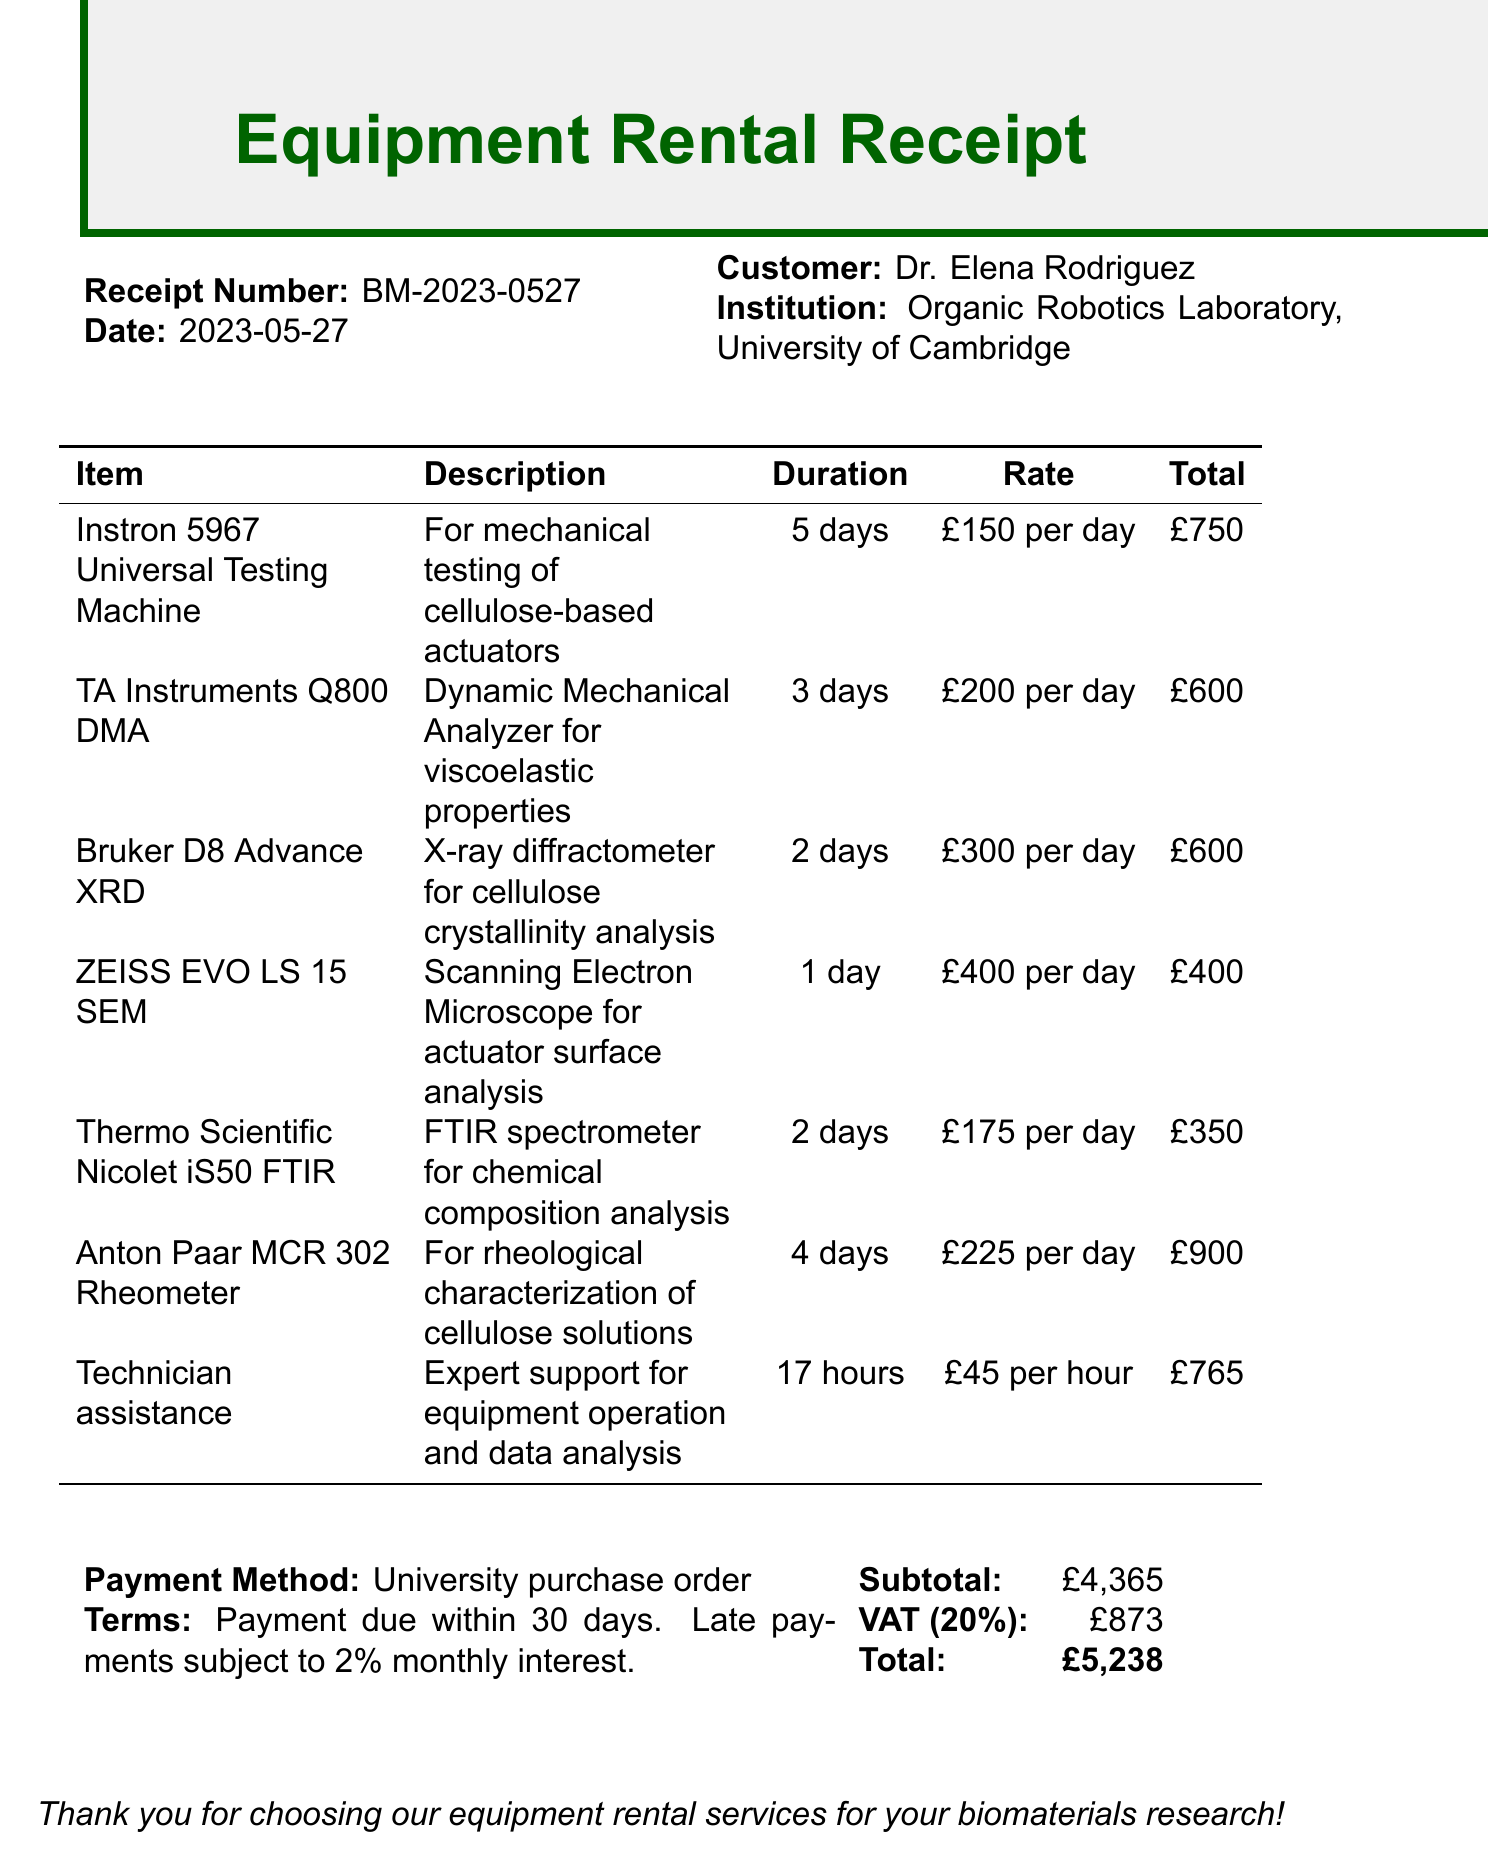What is the receipt number? The receipt number is a unique identifier for this document, found in the header.
Answer: BM-2023-0527 Who is the customer? The customer's name appears next to the label "Customer" in the document.
Answer: Dr. Elena Rodriguez What is the total amount due? The total amount is listed in the payment summary at the bottom of the receipt.
Answer: £5,238 How many days was the Instron 5967 rented? The rental duration is specified in the item list for the Instron 5967.
Answer: 5 days What was the daily rate for the TA Instruments Q800 DMA? The daily rate for the TA Instruments Q800 DMA is indicated in the equipment rental details.
Answer: £200 per day What type of analysis is the Bruker D8 Advance XRD used for? The use of the Bruker D8 Advance XRD is described under its item description in the list.
Answer: Cellulose crystallinity analysis How long did technician assistance last? The duration of technician assistance is specified in the item details.
Answer: 17 hours What is the VAT amount? The VAT amount is shown in the payment summary section of the document.
Answer: £873 What is the payment method? The payment method is indicated under the payment summary.
Answer: University purchase order 